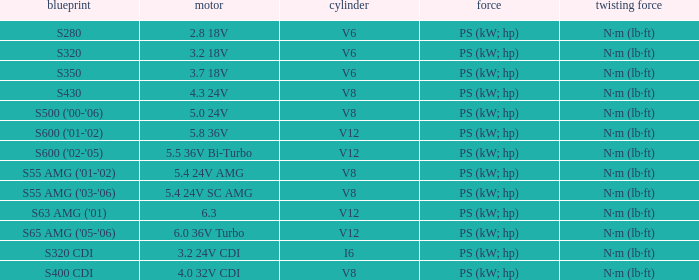Which Torque has a Model of s63 amg ('01)? N·m (lb·ft). 